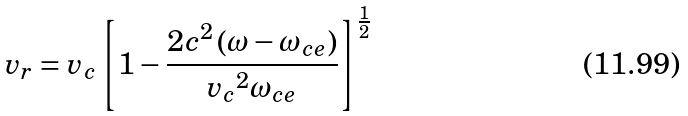<formula> <loc_0><loc_0><loc_500><loc_500>v _ { r } = v _ { c } \left [ { 1 - \frac { 2 c ^ { 2 } \left ( { \omega - \omega _ { c e } } \right ) } { { v _ { c } } ^ { 2 } \omega _ { c e } } } \right ] ^ { \frac { 1 } { 2 } }</formula> 